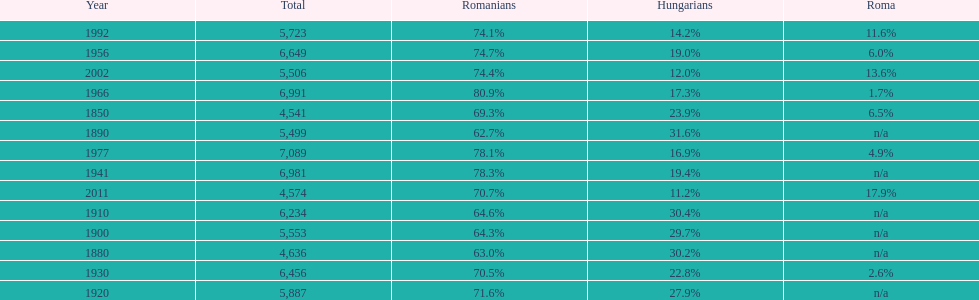Which year had the top percentage in romanian population? 1966. 